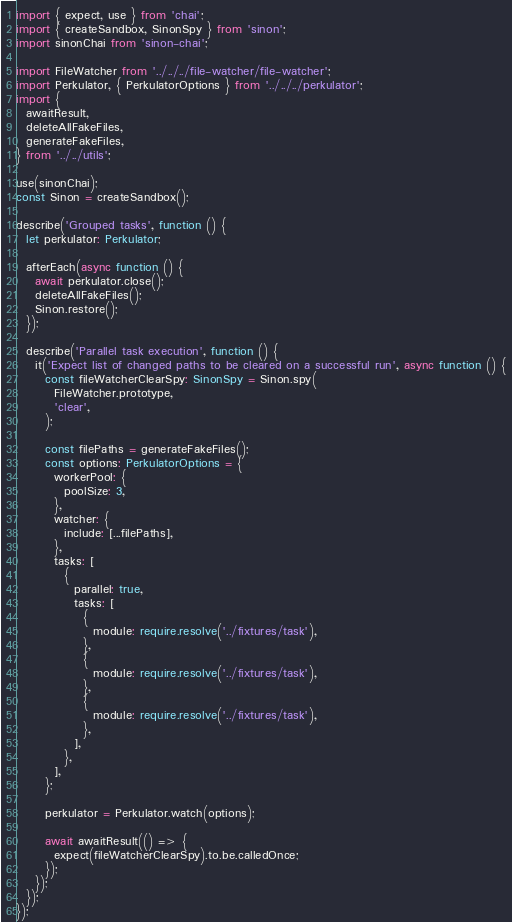<code> <loc_0><loc_0><loc_500><loc_500><_TypeScript_>import { expect, use } from 'chai';
import { createSandbox, SinonSpy } from 'sinon';
import sinonChai from 'sinon-chai';

import FileWatcher from '../../../file-watcher/file-watcher';
import Perkulator, { PerkulatorOptions } from '../../../perkulator';
import {
  awaitResult,
  deleteAllFakeFiles,
  generateFakeFiles,
} from '../../utils';

use(sinonChai);
const Sinon = createSandbox();

describe('Grouped tasks', function () {
  let perkulator: Perkulator;

  afterEach(async function () {
    await perkulator.close();
    deleteAllFakeFiles();
    Sinon.restore();
  });

  describe('Parallel task execution', function () {
    it('Expect list of changed paths to be cleared on a successful run', async function () {
      const fileWatcherClearSpy: SinonSpy = Sinon.spy(
        FileWatcher.prototype,
        'clear',
      );

      const filePaths = generateFakeFiles();
      const options: PerkulatorOptions = {
        workerPool: {
          poolSize: 3,
        },
        watcher: {
          include: [...filePaths],
        },
        tasks: [
          {
            parallel: true,
            tasks: [
              {
                module: require.resolve('../fixtures/task'),
              },
              {
                module: require.resolve('../fixtures/task'),
              },
              {
                module: require.resolve('../fixtures/task'),
              },
            ],
          },
        ],
      };

      perkulator = Perkulator.watch(options);

      await awaitResult(() => {
        expect(fileWatcherClearSpy).to.be.calledOnce;
      });
    });
  });
});
</code> 